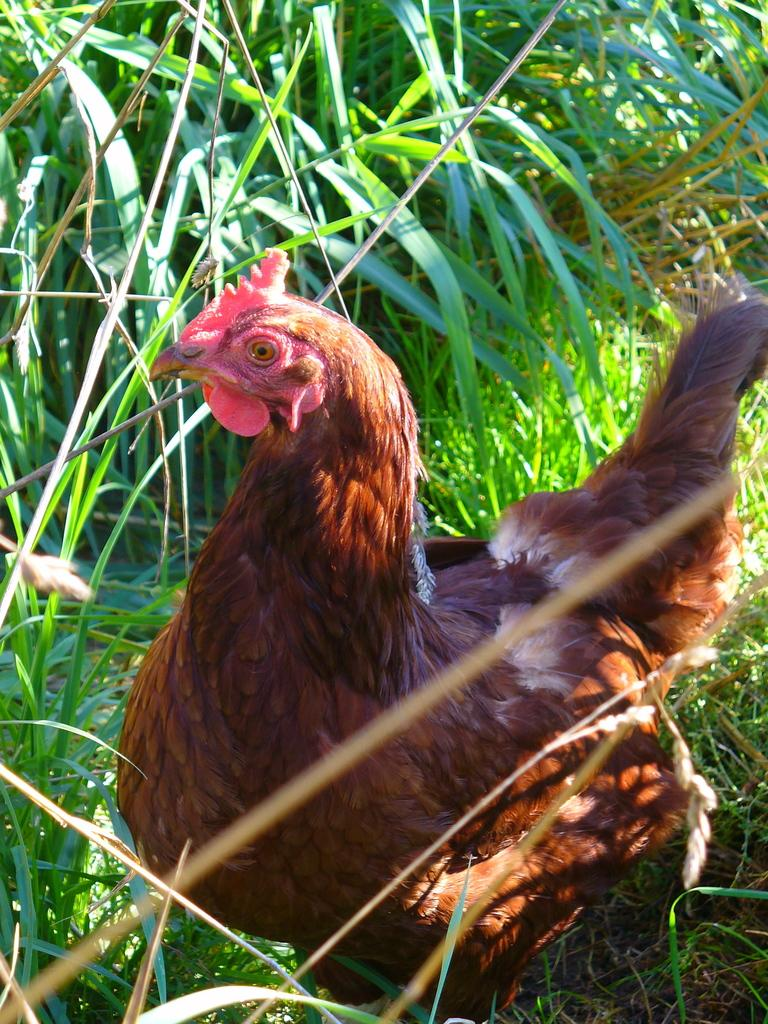What animal is in the picture? There is a hen in the picture. What can be seen behind the hen in the picture? There are plants behind the hen in the picture. What type of steam is coming out of the hen's beak in the picture? There is no steam coming out of the hen's beak in the picture; it is a hen standing among plants. 